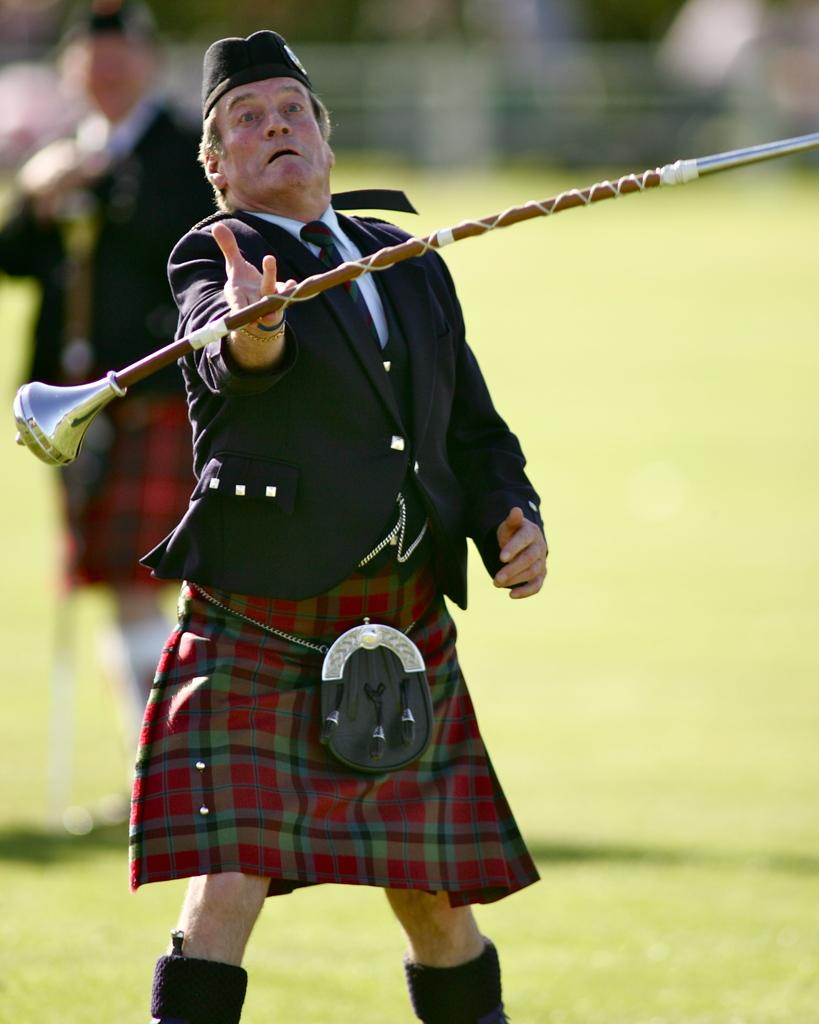What is the main subject in the foreground of the image? There is an old man in the foreground of the image. What is the old man holding in the image? The old man is holding a stick. Can you describe the other person in the image? There is a man standing on the left side of the image. What type of house can be seen in the background of the image? There is no house present in the image; it only features the old man and the man standing on the left side. 